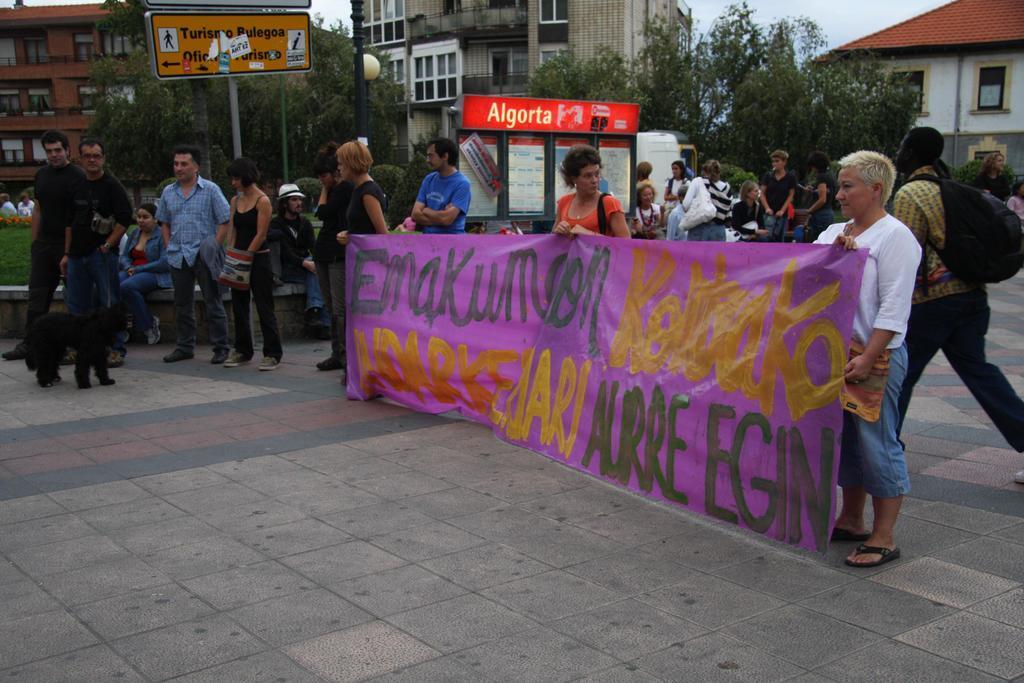How would you summarize this image in a sentence or two? This image is clicked on the road. Three persons are holding a banner and standing on the road. In the background, there are buildings, trees and boards. 